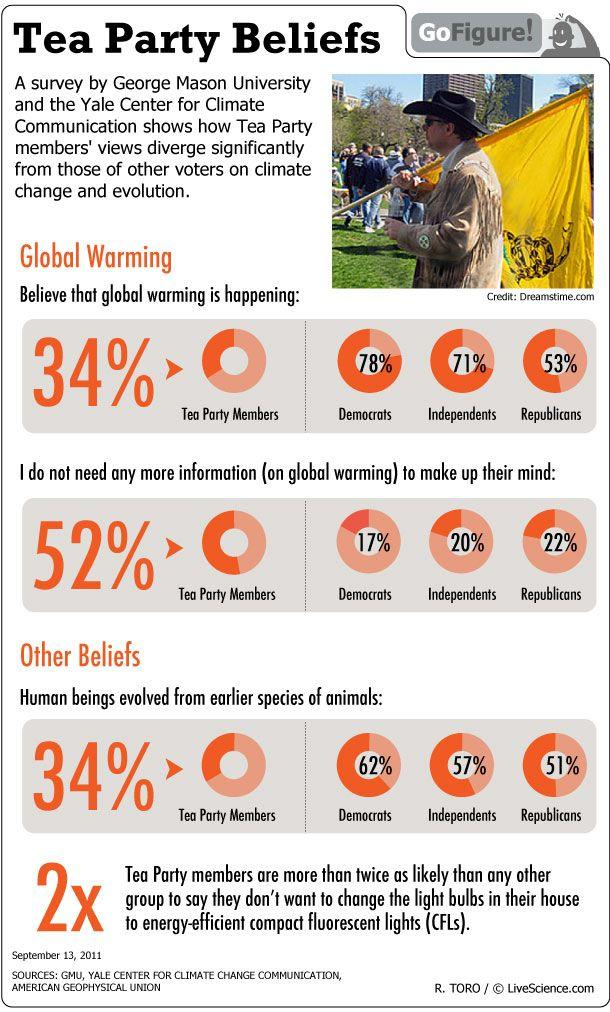List a handful of essential elements in this visual. According to a survey, over 50% of Tea Party members believe that they do not require additional information on global warming. According to a recent survey, 53% of Republicans believe that global warming is occurring. 